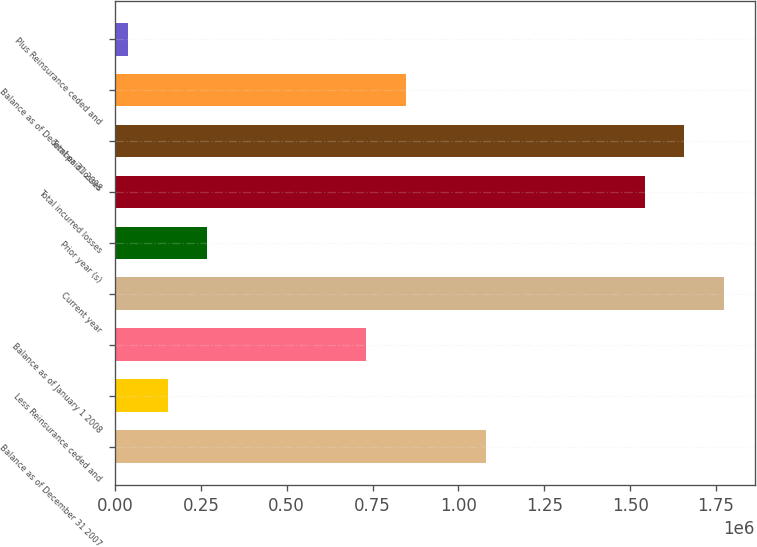<chart> <loc_0><loc_0><loc_500><loc_500><bar_chart><fcel>Balance as of December 31 2007<fcel>Less Reinsurance ceded and<fcel>Balance as of January 1 2008<fcel>Current year<fcel>Prior year (s)<fcel>Total incurred losses<fcel>Total paid losses<fcel>Balance as of December 31 2008<fcel>Plus Reinsurance ceded and<nl><fcel>1.07909e+06<fcel>153024<fcel>731818<fcel>1.77365e+06<fcel>268783<fcel>1.54213e+06<fcel>1.65789e+06<fcel>847577<fcel>37265<nl></chart> 